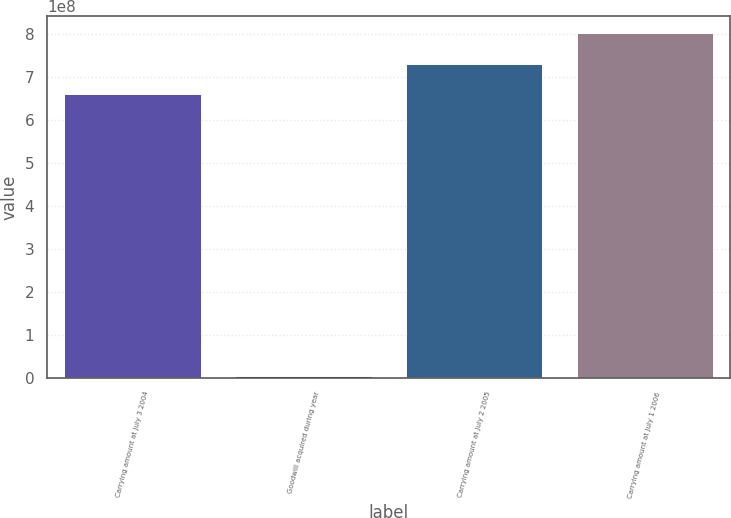Convert chart to OTSL. <chart><loc_0><loc_0><loc_500><loc_500><bar_chart><fcel>Carrying amount at July 3 2004<fcel>Goodwill acquired during year<fcel>Carrying amount at July 2 2005<fcel>Carrying amount at July 1 2006<nl><fcel>6.60098e+08<fcel>3.589e+06<fcel>7.3068e+08<fcel>8.01263e+08<nl></chart> 